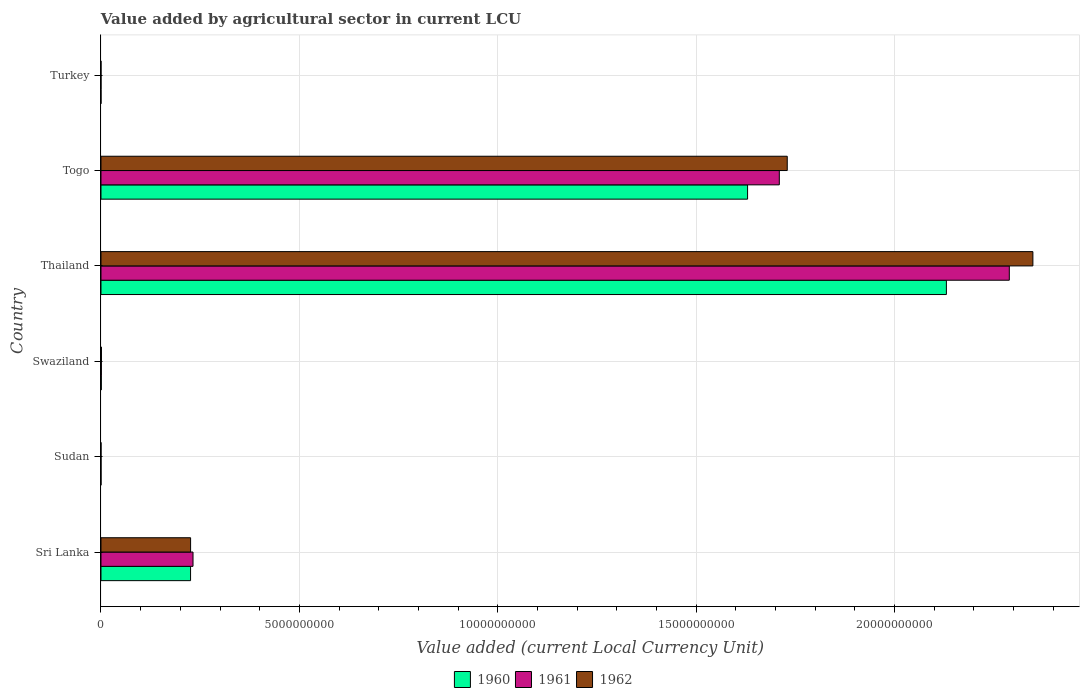How many groups of bars are there?
Make the answer very short. 6. What is the label of the 4th group of bars from the top?
Give a very brief answer. Swaziland. In how many cases, is the number of bars for a given country not equal to the number of legend labels?
Your answer should be very brief. 0. What is the value added by agricultural sector in 1962 in Thailand?
Provide a short and direct response. 2.35e+1. Across all countries, what is the maximum value added by agricultural sector in 1962?
Ensure brevity in your answer.  2.35e+1. Across all countries, what is the minimum value added by agricultural sector in 1960?
Give a very brief answer. 3.74e+04. In which country was the value added by agricultural sector in 1961 maximum?
Provide a succinct answer. Thailand. In which country was the value added by agricultural sector in 1962 minimum?
Your answer should be compact. Turkey. What is the total value added by agricultural sector in 1961 in the graph?
Your answer should be compact. 4.23e+1. What is the difference between the value added by agricultural sector in 1961 in Togo and that in Turkey?
Ensure brevity in your answer.  1.71e+1. What is the difference between the value added by agricultural sector in 1961 in Sudan and the value added by agricultural sector in 1962 in Turkey?
Your answer should be compact. 1.77e+05. What is the average value added by agricultural sector in 1962 per country?
Give a very brief answer. 7.18e+09. What is the difference between the value added by agricultural sector in 1962 and value added by agricultural sector in 1961 in Sudan?
Ensure brevity in your answer.  1.14e+04. In how many countries, is the value added by agricultural sector in 1961 greater than 19000000000 LCU?
Keep it short and to the point. 1. What is the ratio of the value added by agricultural sector in 1960 in Sudan to that in Thailand?
Make the answer very short. 9.464240778581282e-6. What is the difference between the highest and the second highest value added by agricultural sector in 1961?
Ensure brevity in your answer.  5.80e+09. What is the difference between the highest and the lowest value added by agricultural sector in 1961?
Make the answer very short. 2.29e+1. In how many countries, is the value added by agricultural sector in 1961 greater than the average value added by agricultural sector in 1961 taken over all countries?
Provide a succinct answer. 2. What does the 3rd bar from the bottom in Swaziland represents?
Offer a very short reply. 1962. Are all the bars in the graph horizontal?
Give a very brief answer. Yes. How many countries are there in the graph?
Ensure brevity in your answer.  6. What is the difference between two consecutive major ticks on the X-axis?
Provide a succinct answer. 5.00e+09. Does the graph contain any zero values?
Ensure brevity in your answer.  No. Does the graph contain grids?
Make the answer very short. Yes. How many legend labels are there?
Provide a succinct answer. 3. What is the title of the graph?
Give a very brief answer. Value added by agricultural sector in current LCU. Does "1986" appear as one of the legend labels in the graph?
Give a very brief answer. No. What is the label or title of the X-axis?
Give a very brief answer. Value added (current Local Currency Unit). What is the label or title of the Y-axis?
Your answer should be very brief. Country. What is the Value added (current Local Currency Unit) in 1960 in Sri Lanka?
Offer a terse response. 2.26e+09. What is the Value added (current Local Currency Unit) in 1961 in Sri Lanka?
Make the answer very short. 2.32e+09. What is the Value added (current Local Currency Unit) of 1962 in Sri Lanka?
Your answer should be very brief. 2.26e+09. What is the Value added (current Local Currency Unit) in 1960 in Sudan?
Your answer should be compact. 2.02e+05. What is the Value added (current Local Currency Unit) of 1961 in Sudan?
Your response must be concise. 2.19e+05. What is the Value added (current Local Currency Unit) of 1962 in Sudan?
Ensure brevity in your answer.  2.31e+05. What is the Value added (current Local Currency Unit) of 1960 in Swaziland?
Your answer should be very brief. 7.90e+06. What is the Value added (current Local Currency Unit) of 1961 in Swaziland?
Provide a succinct answer. 9.30e+06. What is the Value added (current Local Currency Unit) in 1962 in Swaziland?
Offer a very short reply. 1.14e+07. What is the Value added (current Local Currency Unit) in 1960 in Thailand?
Provide a short and direct response. 2.13e+1. What is the Value added (current Local Currency Unit) in 1961 in Thailand?
Your response must be concise. 2.29e+1. What is the Value added (current Local Currency Unit) of 1962 in Thailand?
Keep it short and to the point. 2.35e+1. What is the Value added (current Local Currency Unit) of 1960 in Togo?
Offer a very short reply. 1.63e+1. What is the Value added (current Local Currency Unit) of 1961 in Togo?
Your response must be concise. 1.71e+1. What is the Value added (current Local Currency Unit) of 1962 in Togo?
Provide a succinct answer. 1.73e+1. What is the Value added (current Local Currency Unit) of 1960 in Turkey?
Offer a very short reply. 3.74e+04. What is the Value added (current Local Currency Unit) of 1961 in Turkey?
Make the answer very short. 3.72e+04. What is the Value added (current Local Currency Unit) in 1962 in Turkey?
Keep it short and to the point. 4.24e+04. Across all countries, what is the maximum Value added (current Local Currency Unit) in 1960?
Your answer should be compact. 2.13e+1. Across all countries, what is the maximum Value added (current Local Currency Unit) in 1961?
Offer a very short reply. 2.29e+1. Across all countries, what is the maximum Value added (current Local Currency Unit) of 1962?
Your answer should be compact. 2.35e+1. Across all countries, what is the minimum Value added (current Local Currency Unit) of 1960?
Offer a terse response. 3.74e+04. Across all countries, what is the minimum Value added (current Local Currency Unit) of 1961?
Keep it short and to the point. 3.72e+04. Across all countries, what is the minimum Value added (current Local Currency Unit) in 1962?
Your response must be concise. 4.24e+04. What is the total Value added (current Local Currency Unit) of 1960 in the graph?
Keep it short and to the point. 3.99e+1. What is the total Value added (current Local Currency Unit) in 1961 in the graph?
Offer a very short reply. 4.23e+1. What is the total Value added (current Local Currency Unit) of 1962 in the graph?
Your answer should be very brief. 4.31e+1. What is the difference between the Value added (current Local Currency Unit) in 1960 in Sri Lanka and that in Sudan?
Give a very brief answer. 2.26e+09. What is the difference between the Value added (current Local Currency Unit) in 1961 in Sri Lanka and that in Sudan?
Your answer should be compact. 2.32e+09. What is the difference between the Value added (current Local Currency Unit) of 1962 in Sri Lanka and that in Sudan?
Your response must be concise. 2.26e+09. What is the difference between the Value added (current Local Currency Unit) of 1960 in Sri Lanka and that in Swaziland?
Provide a succinct answer. 2.25e+09. What is the difference between the Value added (current Local Currency Unit) in 1961 in Sri Lanka and that in Swaziland?
Provide a succinct answer. 2.31e+09. What is the difference between the Value added (current Local Currency Unit) in 1962 in Sri Lanka and that in Swaziland?
Keep it short and to the point. 2.25e+09. What is the difference between the Value added (current Local Currency Unit) of 1960 in Sri Lanka and that in Thailand?
Your answer should be very brief. -1.91e+1. What is the difference between the Value added (current Local Currency Unit) in 1961 in Sri Lanka and that in Thailand?
Your response must be concise. -2.06e+1. What is the difference between the Value added (current Local Currency Unit) in 1962 in Sri Lanka and that in Thailand?
Provide a succinct answer. -2.12e+1. What is the difference between the Value added (current Local Currency Unit) in 1960 in Sri Lanka and that in Togo?
Give a very brief answer. -1.40e+1. What is the difference between the Value added (current Local Currency Unit) of 1961 in Sri Lanka and that in Togo?
Ensure brevity in your answer.  -1.48e+1. What is the difference between the Value added (current Local Currency Unit) in 1962 in Sri Lanka and that in Togo?
Keep it short and to the point. -1.50e+1. What is the difference between the Value added (current Local Currency Unit) of 1960 in Sri Lanka and that in Turkey?
Your answer should be very brief. 2.26e+09. What is the difference between the Value added (current Local Currency Unit) of 1961 in Sri Lanka and that in Turkey?
Your answer should be compact. 2.32e+09. What is the difference between the Value added (current Local Currency Unit) in 1962 in Sri Lanka and that in Turkey?
Ensure brevity in your answer.  2.26e+09. What is the difference between the Value added (current Local Currency Unit) of 1960 in Sudan and that in Swaziland?
Keep it short and to the point. -7.70e+06. What is the difference between the Value added (current Local Currency Unit) in 1961 in Sudan and that in Swaziland?
Keep it short and to the point. -9.08e+06. What is the difference between the Value added (current Local Currency Unit) in 1962 in Sudan and that in Swaziland?
Keep it short and to the point. -1.12e+07. What is the difference between the Value added (current Local Currency Unit) in 1960 in Sudan and that in Thailand?
Offer a very short reply. -2.13e+1. What is the difference between the Value added (current Local Currency Unit) of 1961 in Sudan and that in Thailand?
Offer a very short reply. -2.29e+1. What is the difference between the Value added (current Local Currency Unit) of 1962 in Sudan and that in Thailand?
Keep it short and to the point. -2.35e+1. What is the difference between the Value added (current Local Currency Unit) of 1960 in Sudan and that in Togo?
Give a very brief answer. -1.63e+1. What is the difference between the Value added (current Local Currency Unit) of 1961 in Sudan and that in Togo?
Give a very brief answer. -1.71e+1. What is the difference between the Value added (current Local Currency Unit) in 1962 in Sudan and that in Togo?
Provide a short and direct response. -1.73e+1. What is the difference between the Value added (current Local Currency Unit) of 1960 in Sudan and that in Turkey?
Make the answer very short. 1.64e+05. What is the difference between the Value added (current Local Currency Unit) in 1961 in Sudan and that in Turkey?
Ensure brevity in your answer.  1.82e+05. What is the difference between the Value added (current Local Currency Unit) of 1962 in Sudan and that in Turkey?
Offer a terse response. 1.88e+05. What is the difference between the Value added (current Local Currency Unit) in 1960 in Swaziland and that in Thailand?
Ensure brevity in your answer.  -2.13e+1. What is the difference between the Value added (current Local Currency Unit) in 1961 in Swaziland and that in Thailand?
Give a very brief answer. -2.29e+1. What is the difference between the Value added (current Local Currency Unit) of 1962 in Swaziland and that in Thailand?
Provide a short and direct response. -2.35e+1. What is the difference between the Value added (current Local Currency Unit) in 1960 in Swaziland and that in Togo?
Provide a short and direct response. -1.63e+1. What is the difference between the Value added (current Local Currency Unit) of 1961 in Swaziland and that in Togo?
Provide a short and direct response. -1.71e+1. What is the difference between the Value added (current Local Currency Unit) in 1962 in Swaziland and that in Togo?
Provide a succinct answer. -1.73e+1. What is the difference between the Value added (current Local Currency Unit) of 1960 in Swaziland and that in Turkey?
Provide a short and direct response. 7.86e+06. What is the difference between the Value added (current Local Currency Unit) of 1961 in Swaziland and that in Turkey?
Give a very brief answer. 9.26e+06. What is the difference between the Value added (current Local Currency Unit) of 1962 in Swaziland and that in Turkey?
Offer a very short reply. 1.14e+07. What is the difference between the Value added (current Local Currency Unit) in 1960 in Thailand and that in Togo?
Provide a short and direct response. 5.01e+09. What is the difference between the Value added (current Local Currency Unit) in 1961 in Thailand and that in Togo?
Make the answer very short. 5.80e+09. What is the difference between the Value added (current Local Currency Unit) in 1962 in Thailand and that in Togo?
Your answer should be compact. 6.19e+09. What is the difference between the Value added (current Local Currency Unit) of 1960 in Thailand and that in Turkey?
Your answer should be very brief. 2.13e+1. What is the difference between the Value added (current Local Currency Unit) in 1961 in Thailand and that in Turkey?
Keep it short and to the point. 2.29e+1. What is the difference between the Value added (current Local Currency Unit) of 1962 in Thailand and that in Turkey?
Give a very brief answer. 2.35e+1. What is the difference between the Value added (current Local Currency Unit) in 1960 in Togo and that in Turkey?
Offer a terse response. 1.63e+1. What is the difference between the Value added (current Local Currency Unit) in 1961 in Togo and that in Turkey?
Offer a very short reply. 1.71e+1. What is the difference between the Value added (current Local Currency Unit) of 1962 in Togo and that in Turkey?
Provide a succinct answer. 1.73e+1. What is the difference between the Value added (current Local Currency Unit) of 1960 in Sri Lanka and the Value added (current Local Currency Unit) of 1961 in Sudan?
Keep it short and to the point. 2.26e+09. What is the difference between the Value added (current Local Currency Unit) of 1960 in Sri Lanka and the Value added (current Local Currency Unit) of 1962 in Sudan?
Your response must be concise. 2.26e+09. What is the difference between the Value added (current Local Currency Unit) of 1961 in Sri Lanka and the Value added (current Local Currency Unit) of 1962 in Sudan?
Make the answer very short. 2.32e+09. What is the difference between the Value added (current Local Currency Unit) of 1960 in Sri Lanka and the Value added (current Local Currency Unit) of 1961 in Swaziland?
Ensure brevity in your answer.  2.25e+09. What is the difference between the Value added (current Local Currency Unit) in 1960 in Sri Lanka and the Value added (current Local Currency Unit) in 1962 in Swaziland?
Make the answer very short. 2.25e+09. What is the difference between the Value added (current Local Currency Unit) in 1961 in Sri Lanka and the Value added (current Local Currency Unit) in 1962 in Swaziland?
Provide a succinct answer. 2.31e+09. What is the difference between the Value added (current Local Currency Unit) in 1960 in Sri Lanka and the Value added (current Local Currency Unit) in 1961 in Thailand?
Your response must be concise. -2.06e+1. What is the difference between the Value added (current Local Currency Unit) in 1960 in Sri Lanka and the Value added (current Local Currency Unit) in 1962 in Thailand?
Your answer should be compact. -2.12e+1. What is the difference between the Value added (current Local Currency Unit) of 1961 in Sri Lanka and the Value added (current Local Currency Unit) of 1962 in Thailand?
Give a very brief answer. -2.12e+1. What is the difference between the Value added (current Local Currency Unit) in 1960 in Sri Lanka and the Value added (current Local Currency Unit) in 1961 in Togo?
Provide a succinct answer. -1.48e+1. What is the difference between the Value added (current Local Currency Unit) of 1960 in Sri Lanka and the Value added (current Local Currency Unit) of 1962 in Togo?
Make the answer very short. -1.50e+1. What is the difference between the Value added (current Local Currency Unit) in 1961 in Sri Lanka and the Value added (current Local Currency Unit) in 1962 in Togo?
Your response must be concise. -1.50e+1. What is the difference between the Value added (current Local Currency Unit) of 1960 in Sri Lanka and the Value added (current Local Currency Unit) of 1961 in Turkey?
Provide a short and direct response. 2.26e+09. What is the difference between the Value added (current Local Currency Unit) of 1960 in Sri Lanka and the Value added (current Local Currency Unit) of 1962 in Turkey?
Offer a terse response. 2.26e+09. What is the difference between the Value added (current Local Currency Unit) of 1961 in Sri Lanka and the Value added (current Local Currency Unit) of 1962 in Turkey?
Provide a succinct answer. 2.32e+09. What is the difference between the Value added (current Local Currency Unit) of 1960 in Sudan and the Value added (current Local Currency Unit) of 1961 in Swaziland?
Your answer should be compact. -9.10e+06. What is the difference between the Value added (current Local Currency Unit) in 1960 in Sudan and the Value added (current Local Currency Unit) in 1962 in Swaziland?
Offer a very short reply. -1.12e+07. What is the difference between the Value added (current Local Currency Unit) in 1961 in Sudan and the Value added (current Local Currency Unit) in 1962 in Swaziland?
Your answer should be compact. -1.12e+07. What is the difference between the Value added (current Local Currency Unit) in 1960 in Sudan and the Value added (current Local Currency Unit) in 1961 in Thailand?
Your answer should be very brief. -2.29e+1. What is the difference between the Value added (current Local Currency Unit) in 1960 in Sudan and the Value added (current Local Currency Unit) in 1962 in Thailand?
Provide a short and direct response. -2.35e+1. What is the difference between the Value added (current Local Currency Unit) of 1961 in Sudan and the Value added (current Local Currency Unit) of 1962 in Thailand?
Make the answer very short. -2.35e+1. What is the difference between the Value added (current Local Currency Unit) of 1960 in Sudan and the Value added (current Local Currency Unit) of 1961 in Togo?
Provide a short and direct response. -1.71e+1. What is the difference between the Value added (current Local Currency Unit) of 1960 in Sudan and the Value added (current Local Currency Unit) of 1962 in Togo?
Your answer should be compact. -1.73e+1. What is the difference between the Value added (current Local Currency Unit) of 1961 in Sudan and the Value added (current Local Currency Unit) of 1962 in Togo?
Provide a short and direct response. -1.73e+1. What is the difference between the Value added (current Local Currency Unit) in 1960 in Sudan and the Value added (current Local Currency Unit) in 1961 in Turkey?
Provide a short and direct response. 1.64e+05. What is the difference between the Value added (current Local Currency Unit) in 1960 in Sudan and the Value added (current Local Currency Unit) in 1962 in Turkey?
Provide a short and direct response. 1.59e+05. What is the difference between the Value added (current Local Currency Unit) in 1961 in Sudan and the Value added (current Local Currency Unit) in 1962 in Turkey?
Provide a succinct answer. 1.77e+05. What is the difference between the Value added (current Local Currency Unit) in 1960 in Swaziland and the Value added (current Local Currency Unit) in 1961 in Thailand?
Your answer should be very brief. -2.29e+1. What is the difference between the Value added (current Local Currency Unit) of 1960 in Swaziland and the Value added (current Local Currency Unit) of 1962 in Thailand?
Your answer should be compact. -2.35e+1. What is the difference between the Value added (current Local Currency Unit) in 1961 in Swaziland and the Value added (current Local Currency Unit) in 1962 in Thailand?
Your answer should be very brief. -2.35e+1. What is the difference between the Value added (current Local Currency Unit) in 1960 in Swaziland and the Value added (current Local Currency Unit) in 1961 in Togo?
Provide a succinct answer. -1.71e+1. What is the difference between the Value added (current Local Currency Unit) of 1960 in Swaziland and the Value added (current Local Currency Unit) of 1962 in Togo?
Ensure brevity in your answer.  -1.73e+1. What is the difference between the Value added (current Local Currency Unit) of 1961 in Swaziland and the Value added (current Local Currency Unit) of 1962 in Togo?
Offer a terse response. -1.73e+1. What is the difference between the Value added (current Local Currency Unit) of 1960 in Swaziland and the Value added (current Local Currency Unit) of 1961 in Turkey?
Your response must be concise. 7.86e+06. What is the difference between the Value added (current Local Currency Unit) of 1960 in Swaziland and the Value added (current Local Currency Unit) of 1962 in Turkey?
Make the answer very short. 7.86e+06. What is the difference between the Value added (current Local Currency Unit) in 1961 in Swaziland and the Value added (current Local Currency Unit) in 1962 in Turkey?
Ensure brevity in your answer.  9.26e+06. What is the difference between the Value added (current Local Currency Unit) of 1960 in Thailand and the Value added (current Local Currency Unit) of 1961 in Togo?
Your answer should be very brief. 4.21e+09. What is the difference between the Value added (current Local Currency Unit) in 1960 in Thailand and the Value added (current Local Currency Unit) in 1962 in Togo?
Provide a succinct answer. 4.01e+09. What is the difference between the Value added (current Local Currency Unit) in 1961 in Thailand and the Value added (current Local Currency Unit) in 1962 in Togo?
Your answer should be compact. 5.60e+09. What is the difference between the Value added (current Local Currency Unit) in 1960 in Thailand and the Value added (current Local Currency Unit) in 1961 in Turkey?
Your answer should be compact. 2.13e+1. What is the difference between the Value added (current Local Currency Unit) in 1960 in Thailand and the Value added (current Local Currency Unit) in 1962 in Turkey?
Your answer should be compact. 2.13e+1. What is the difference between the Value added (current Local Currency Unit) of 1961 in Thailand and the Value added (current Local Currency Unit) of 1962 in Turkey?
Your answer should be very brief. 2.29e+1. What is the difference between the Value added (current Local Currency Unit) in 1960 in Togo and the Value added (current Local Currency Unit) in 1961 in Turkey?
Give a very brief answer. 1.63e+1. What is the difference between the Value added (current Local Currency Unit) of 1960 in Togo and the Value added (current Local Currency Unit) of 1962 in Turkey?
Make the answer very short. 1.63e+1. What is the difference between the Value added (current Local Currency Unit) of 1961 in Togo and the Value added (current Local Currency Unit) of 1962 in Turkey?
Offer a terse response. 1.71e+1. What is the average Value added (current Local Currency Unit) in 1960 per country?
Your answer should be compact. 6.65e+09. What is the average Value added (current Local Currency Unit) of 1961 per country?
Your answer should be compact. 7.05e+09. What is the average Value added (current Local Currency Unit) in 1962 per country?
Your answer should be compact. 7.18e+09. What is the difference between the Value added (current Local Currency Unit) of 1960 and Value added (current Local Currency Unit) of 1961 in Sri Lanka?
Offer a very short reply. -6.20e+07. What is the difference between the Value added (current Local Currency Unit) in 1961 and Value added (current Local Currency Unit) in 1962 in Sri Lanka?
Offer a terse response. 6.10e+07. What is the difference between the Value added (current Local Currency Unit) of 1960 and Value added (current Local Currency Unit) of 1961 in Sudan?
Your answer should be very brief. -1.76e+04. What is the difference between the Value added (current Local Currency Unit) of 1960 and Value added (current Local Currency Unit) of 1962 in Sudan?
Provide a short and direct response. -2.90e+04. What is the difference between the Value added (current Local Currency Unit) in 1961 and Value added (current Local Currency Unit) in 1962 in Sudan?
Offer a very short reply. -1.14e+04. What is the difference between the Value added (current Local Currency Unit) in 1960 and Value added (current Local Currency Unit) in 1961 in Swaziland?
Your answer should be compact. -1.40e+06. What is the difference between the Value added (current Local Currency Unit) of 1960 and Value added (current Local Currency Unit) of 1962 in Swaziland?
Ensure brevity in your answer.  -3.50e+06. What is the difference between the Value added (current Local Currency Unit) of 1961 and Value added (current Local Currency Unit) of 1962 in Swaziland?
Give a very brief answer. -2.10e+06. What is the difference between the Value added (current Local Currency Unit) in 1960 and Value added (current Local Currency Unit) in 1961 in Thailand?
Your response must be concise. -1.59e+09. What is the difference between the Value added (current Local Currency Unit) of 1960 and Value added (current Local Currency Unit) of 1962 in Thailand?
Provide a succinct answer. -2.18e+09. What is the difference between the Value added (current Local Currency Unit) in 1961 and Value added (current Local Currency Unit) in 1962 in Thailand?
Offer a very short reply. -5.95e+08. What is the difference between the Value added (current Local Currency Unit) of 1960 and Value added (current Local Currency Unit) of 1961 in Togo?
Provide a short and direct response. -8.00e+08. What is the difference between the Value added (current Local Currency Unit) of 1960 and Value added (current Local Currency Unit) of 1962 in Togo?
Ensure brevity in your answer.  -1.00e+09. What is the difference between the Value added (current Local Currency Unit) in 1961 and Value added (current Local Currency Unit) in 1962 in Togo?
Keep it short and to the point. -2.00e+08. What is the difference between the Value added (current Local Currency Unit) of 1960 and Value added (current Local Currency Unit) of 1962 in Turkey?
Your answer should be very brief. -5000. What is the difference between the Value added (current Local Currency Unit) of 1961 and Value added (current Local Currency Unit) of 1962 in Turkey?
Make the answer very short. -5200. What is the ratio of the Value added (current Local Currency Unit) of 1960 in Sri Lanka to that in Sudan?
Offer a very short reply. 1.12e+04. What is the ratio of the Value added (current Local Currency Unit) of 1961 in Sri Lanka to that in Sudan?
Make the answer very short. 1.06e+04. What is the ratio of the Value added (current Local Currency Unit) of 1962 in Sri Lanka to that in Sudan?
Give a very brief answer. 9791.94. What is the ratio of the Value added (current Local Currency Unit) in 1960 in Sri Lanka to that in Swaziland?
Give a very brief answer. 285.82. What is the ratio of the Value added (current Local Currency Unit) in 1961 in Sri Lanka to that in Swaziland?
Ensure brevity in your answer.  249.46. What is the ratio of the Value added (current Local Currency Unit) of 1962 in Sri Lanka to that in Swaziland?
Give a very brief answer. 198.16. What is the ratio of the Value added (current Local Currency Unit) of 1960 in Sri Lanka to that in Thailand?
Make the answer very short. 0.11. What is the ratio of the Value added (current Local Currency Unit) of 1961 in Sri Lanka to that in Thailand?
Provide a short and direct response. 0.1. What is the ratio of the Value added (current Local Currency Unit) of 1962 in Sri Lanka to that in Thailand?
Offer a terse response. 0.1. What is the ratio of the Value added (current Local Currency Unit) of 1960 in Sri Lanka to that in Togo?
Ensure brevity in your answer.  0.14. What is the ratio of the Value added (current Local Currency Unit) in 1961 in Sri Lanka to that in Togo?
Make the answer very short. 0.14. What is the ratio of the Value added (current Local Currency Unit) in 1962 in Sri Lanka to that in Togo?
Your answer should be very brief. 0.13. What is the ratio of the Value added (current Local Currency Unit) in 1960 in Sri Lanka to that in Turkey?
Offer a very short reply. 6.04e+04. What is the ratio of the Value added (current Local Currency Unit) of 1961 in Sri Lanka to that in Turkey?
Keep it short and to the point. 6.24e+04. What is the ratio of the Value added (current Local Currency Unit) of 1962 in Sri Lanka to that in Turkey?
Offer a very short reply. 5.33e+04. What is the ratio of the Value added (current Local Currency Unit) in 1960 in Sudan to that in Swaziland?
Give a very brief answer. 0.03. What is the ratio of the Value added (current Local Currency Unit) of 1961 in Sudan to that in Swaziland?
Your response must be concise. 0.02. What is the ratio of the Value added (current Local Currency Unit) in 1962 in Sudan to that in Swaziland?
Offer a very short reply. 0.02. What is the ratio of the Value added (current Local Currency Unit) in 1960 in Sudan to that in Thailand?
Give a very brief answer. 0. What is the ratio of the Value added (current Local Currency Unit) of 1961 in Sudan to that in Thailand?
Make the answer very short. 0. What is the ratio of the Value added (current Local Currency Unit) of 1961 in Sudan to that in Togo?
Give a very brief answer. 0. What is the ratio of the Value added (current Local Currency Unit) in 1962 in Sudan to that in Togo?
Your answer should be compact. 0. What is the ratio of the Value added (current Local Currency Unit) in 1960 in Sudan to that in Turkey?
Provide a succinct answer. 5.39. What is the ratio of the Value added (current Local Currency Unit) of 1961 in Sudan to that in Turkey?
Offer a very short reply. 5.9. What is the ratio of the Value added (current Local Currency Unit) of 1962 in Sudan to that in Turkey?
Your response must be concise. 5.44. What is the ratio of the Value added (current Local Currency Unit) in 1960 in Swaziland to that in Thailand?
Provide a succinct answer. 0. What is the ratio of the Value added (current Local Currency Unit) in 1961 in Swaziland to that in Togo?
Your response must be concise. 0. What is the ratio of the Value added (current Local Currency Unit) in 1962 in Swaziland to that in Togo?
Give a very brief answer. 0. What is the ratio of the Value added (current Local Currency Unit) in 1960 in Swaziland to that in Turkey?
Offer a terse response. 211.23. What is the ratio of the Value added (current Local Currency Unit) in 1961 in Swaziland to that in Turkey?
Ensure brevity in your answer.  250. What is the ratio of the Value added (current Local Currency Unit) of 1962 in Swaziland to that in Turkey?
Make the answer very short. 268.87. What is the ratio of the Value added (current Local Currency Unit) in 1960 in Thailand to that in Togo?
Offer a terse response. 1.31. What is the ratio of the Value added (current Local Currency Unit) in 1961 in Thailand to that in Togo?
Your response must be concise. 1.34. What is the ratio of the Value added (current Local Currency Unit) in 1962 in Thailand to that in Togo?
Keep it short and to the point. 1.36. What is the ratio of the Value added (current Local Currency Unit) of 1960 in Thailand to that in Turkey?
Provide a short and direct response. 5.70e+05. What is the ratio of the Value added (current Local Currency Unit) of 1961 in Thailand to that in Turkey?
Ensure brevity in your answer.  6.16e+05. What is the ratio of the Value added (current Local Currency Unit) in 1962 in Thailand to that in Turkey?
Your answer should be compact. 5.54e+05. What is the ratio of the Value added (current Local Currency Unit) in 1960 in Togo to that in Turkey?
Provide a short and direct response. 4.36e+05. What is the ratio of the Value added (current Local Currency Unit) in 1961 in Togo to that in Turkey?
Your response must be concise. 4.60e+05. What is the ratio of the Value added (current Local Currency Unit) in 1962 in Togo to that in Turkey?
Your response must be concise. 4.08e+05. What is the difference between the highest and the second highest Value added (current Local Currency Unit) of 1960?
Your response must be concise. 5.01e+09. What is the difference between the highest and the second highest Value added (current Local Currency Unit) of 1961?
Your answer should be compact. 5.80e+09. What is the difference between the highest and the second highest Value added (current Local Currency Unit) of 1962?
Your answer should be very brief. 6.19e+09. What is the difference between the highest and the lowest Value added (current Local Currency Unit) in 1960?
Provide a short and direct response. 2.13e+1. What is the difference between the highest and the lowest Value added (current Local Currency Unit) of 1961?
Offer a terse response. 2.29e+1. What is the difference between the highest and the lowest Value added (current Local Currency Unit) of 1962?
Your answer should be very brief. 2.35e+1. 